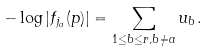Convert formula to latex. <formula><loc_0><loc_0><loc_500><loc_500>- \log | f _ { j _ { a } } ( p ) | = \sum _ { 1 \leq b \leq r , b \neq a } u _ { b } .</formula> 